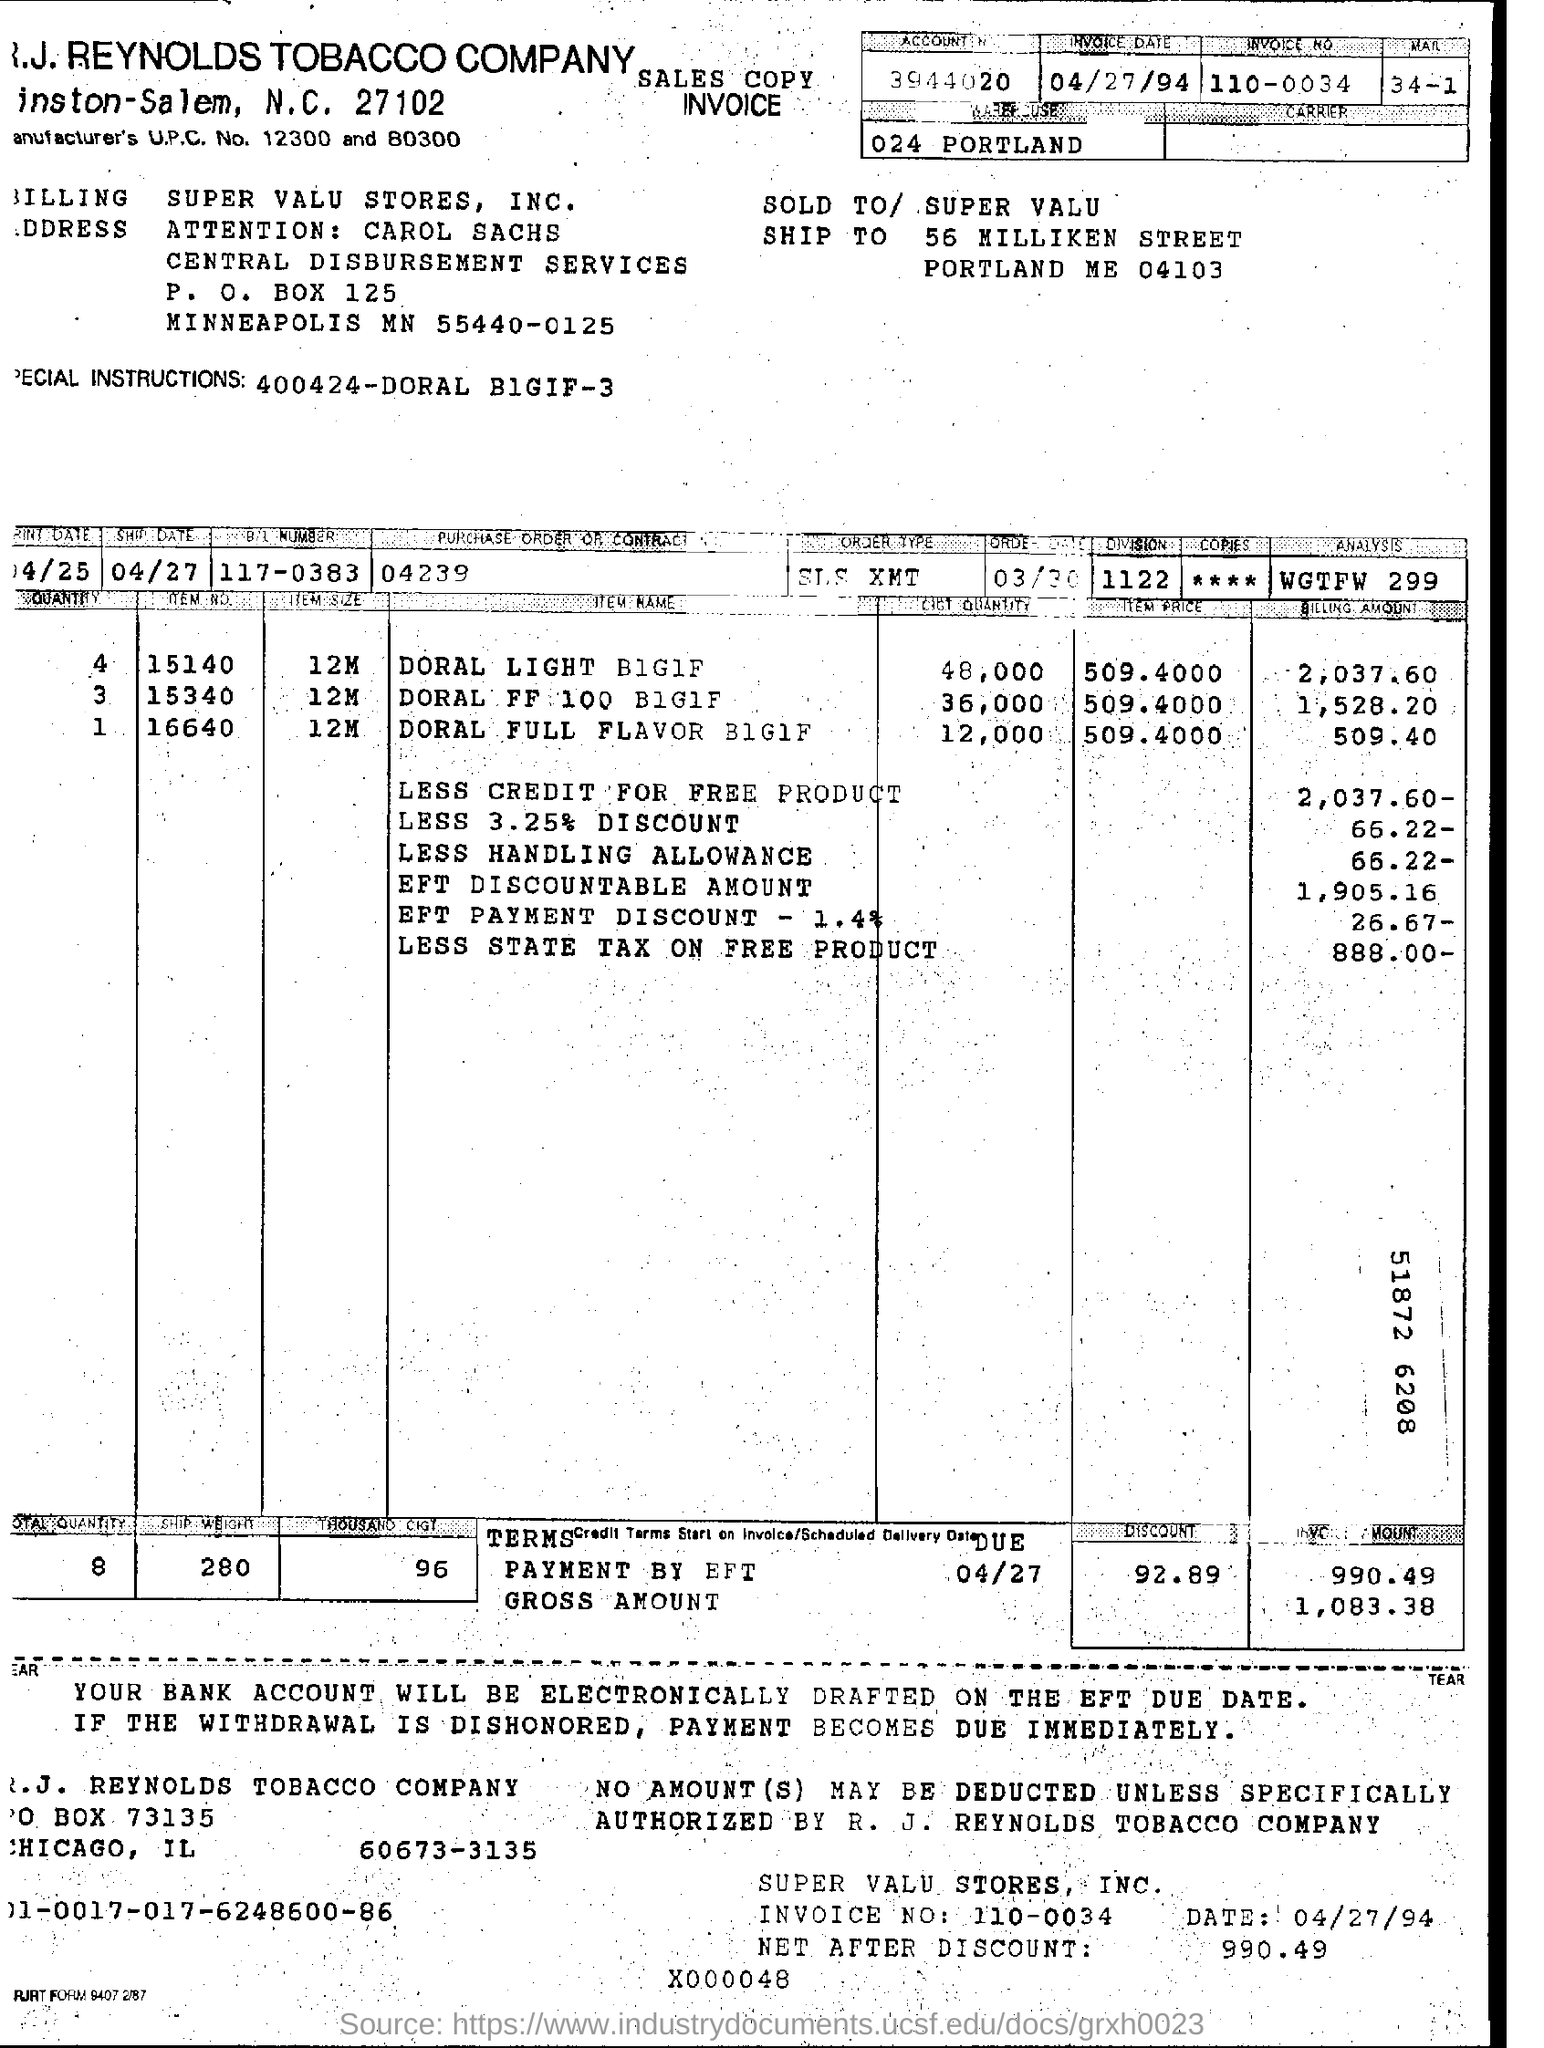What is the invoice date?
Keep it short and to the point. 04/27/94. What is the Invoice Number ?
Ensure brevity in your answer.  110-0034. 